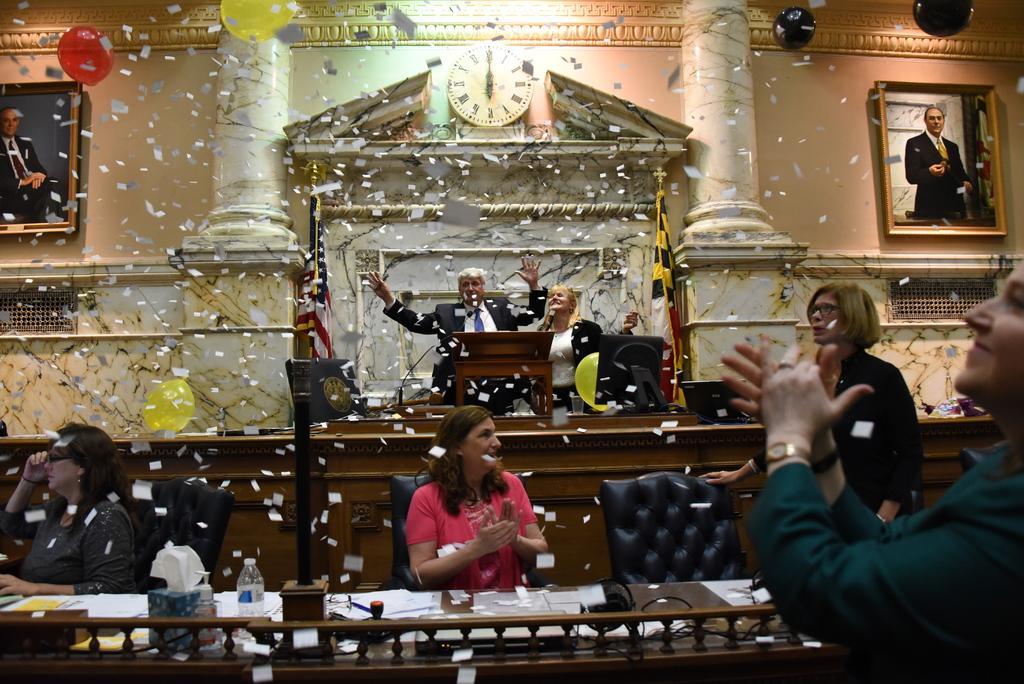Describe this image in one or two sentences. In this image i can see three women two women are sitting and one women is standing at front i can see the other person standing, there are few papers, bottle on a table at the back ground i can see a man and a woman standing in front of a podium holding a micro phone there is a clock, a pillar and a frame attached to a wall. 